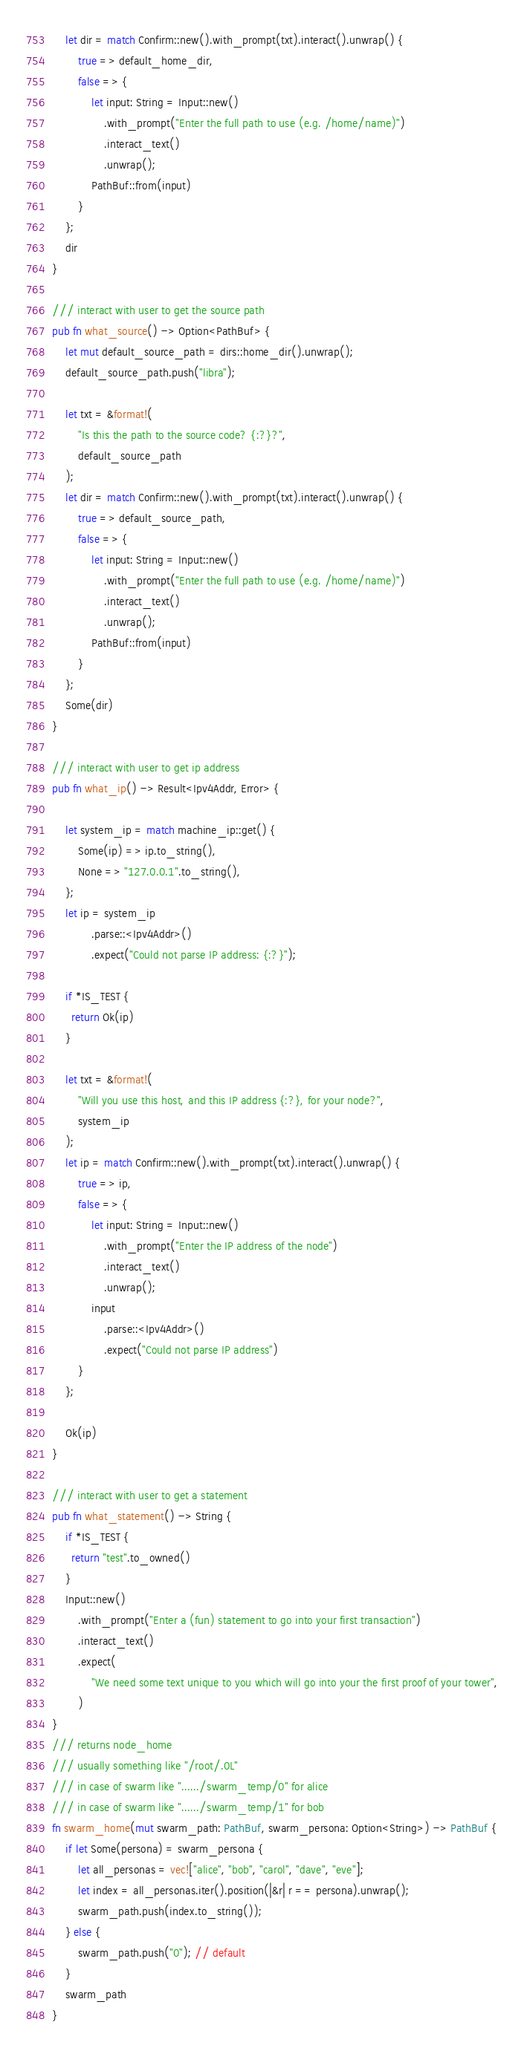Convert code to text. <code><loc_0><loc_0><loc_500><loc_500><_Rust_>    let dir = match Confirm::new().with_prompt(txt).interact().unwrap() {
        true => default_home_dir,
        false => {
            let input: String = Input::new()
                .with_prompt("Enter the full path to use (e.g. /home/name)")
                .interact_text()
                .unwrap();
            PathBuf::from(input)
        }
    };
    dir
}

/// interact with user to get the source path
pub fn what_source() -> Option<PathBuf> {
    let mut default_source_path = dirs::home_dir().unwrap();
    default_source_path.push("libra");

    let txt = &format!(
        "Is this the path to the source code? {:?}?",
        default_source_path
    );
    let dir = match Confirm::new().with_prompt(txt).interact().unwrap() {
        true => default_source_path,
        false => {
            let input: String = Input::new()
                .with_prompt("Enter the full path to use (e.g. /home/name)")
                .interact_text()
                .unwrap();
            PathBuf::from(input)
        }
    };
    Some(dir)
}

/// interact with user to get ip address
pub fn what_ip() -> Result<Ipv4Addr, Error> {

    let system_ip = match machine_ip::get() {
        Some(ip) => ip.to_string(),
        None => "127.0.0.1".to_string(),
    };
    let ip = system_ip
            .parse::<Ipv4Addr>()
            .expect("Could not parse IP address: {:?}");

    if *IS_TEST {
      return Ok(ip)
    }

    let txt = &format!(
        "Will you use this host, and this IP address {:?}, for your node?",
        system_ip
    );
    let ip = match Confirm::new().with_prompt(txt).interact().unwrap() {
        true => ip,
        false => {
            let input: String = Input::new()
                .with_prompt("Enter the IP address of the node")
                .interact_text()
                .unwrap();
            input
                .parse::<Ipv4Addr>()
                .expect("Could not parse IP address")
        }
    };

    Ok(ip)
}

/// interact with user to get a statement
pub fn what_statement() -> String {
    if *IS_TEST {
      return "test".to_owned()
    }
    Input::new()
        .with_prompt("Enter a (fun) statement to go into your first transaction")
        .interact_text()
        .expect(
            "We need some text unique to you which will go into your the first proof of your tower",
        )
}
/// returns node_home
/// usually something like "/root/.0L"
/// in case of swarm like "....../swarm_temp/0" for alice
/// in case of swarm like "....../swarm_temp/1" for bob
fn swarm_home(mut swarm_path: PathBuf, swarm_persona: Option<String>) -> PathBuf {
    if let Some(persona) = swarm_persona {
        let all_personas = vec!["alice", "bob", "carol", "dave", "eve"];
        let index = all_personas.iter().position(|&r| r == persona).unwrap();
        swarm_path.push(index.to_string());
    } else {
        swarm_path.push("0"); // default
    }
    swarm_path
}
</code> 